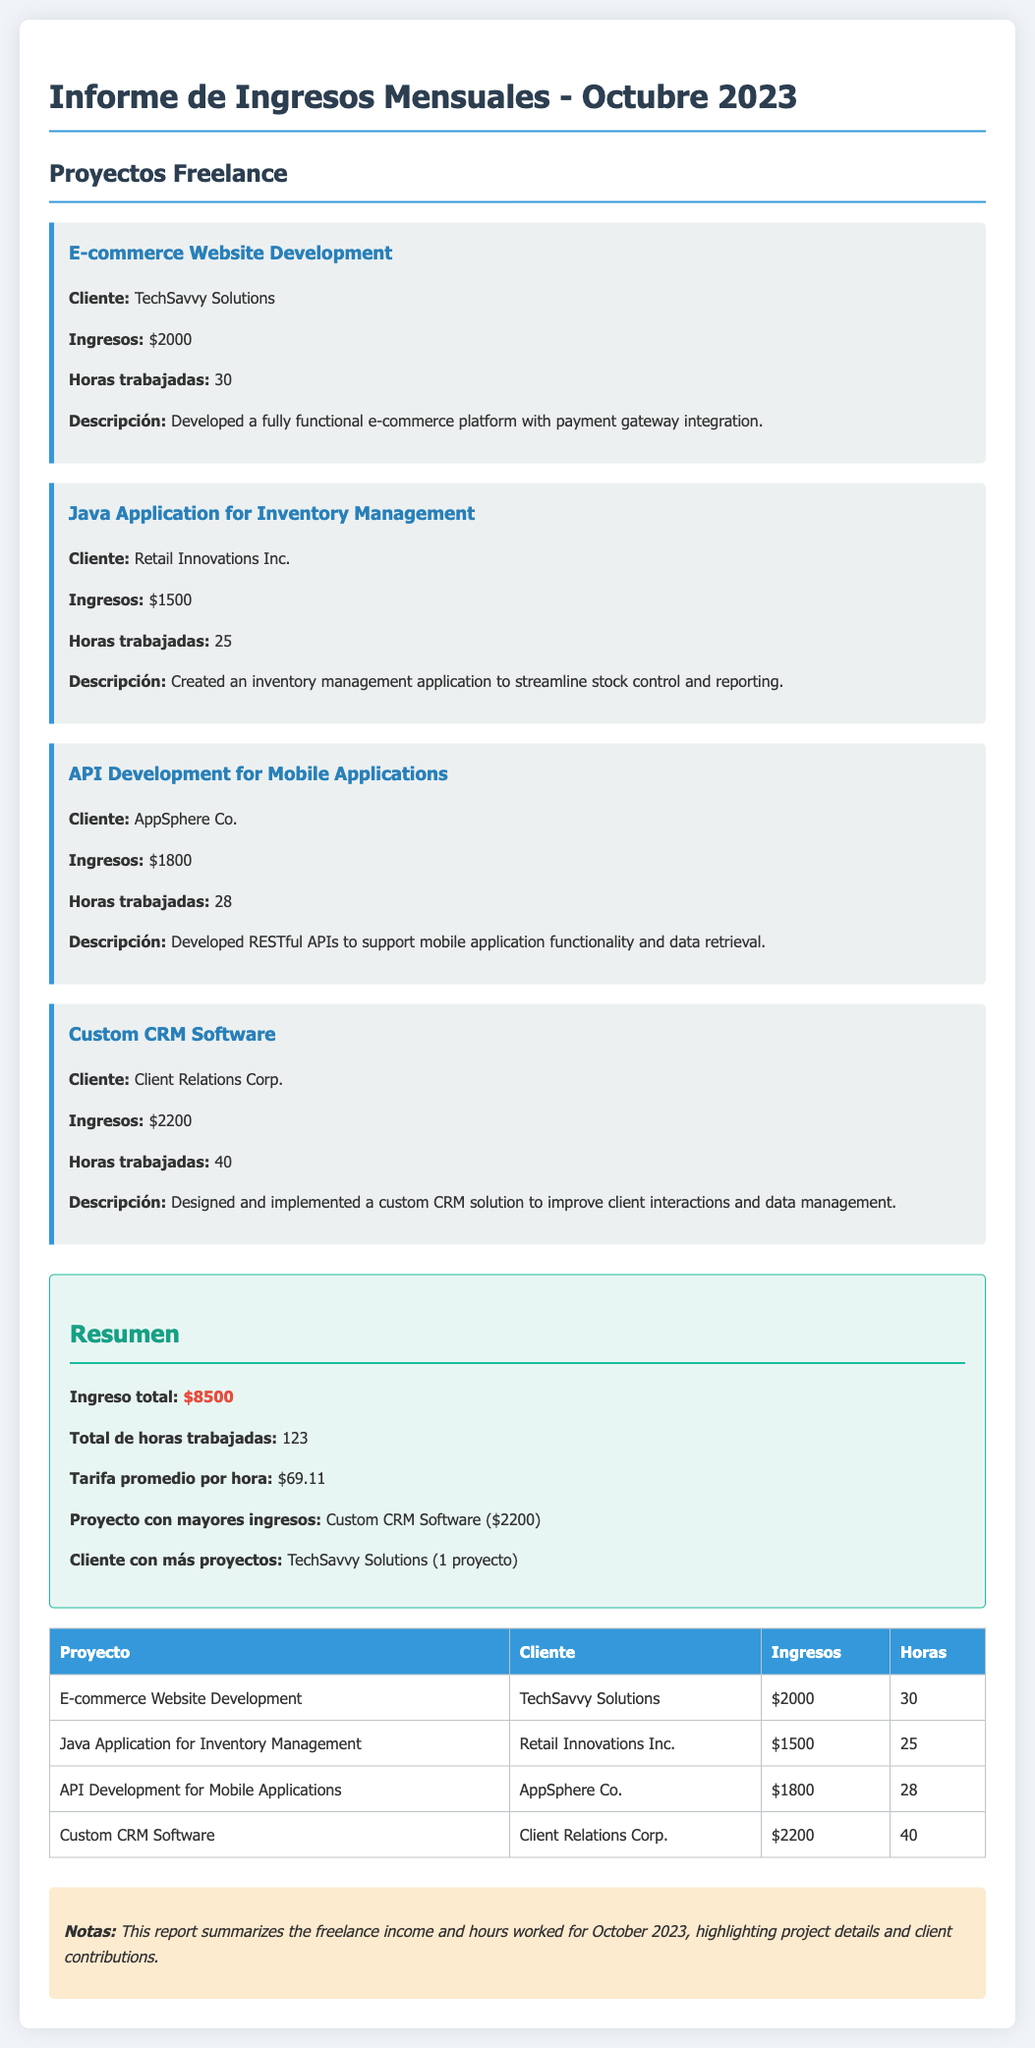what is the total revenue? The total revenue is the sum of all incomes from the projects listed in the document, which adds up to $8500.
Answer: $8500 who is the client for the API Development project? The client for the API Development for Mobile Applications project is mentioned in the document as AppSphere Co.
Answer: AppSphere Co how many hours were worked on the Custom CRM Software project? The document specifies that 40 hours were worked on the Custom CRM Software project.
Answer: 40 which project generated the highest income? The project that generated the highest income is detailed in the summary section as Custom CRM Software, with an income of $2200.
Answer: Custom CRM Software what is the average hourly rate calculated from the total income and hours worked? The average hourly rate is calculated as total income divided by total hours worked, resulting in a rate of $69.11.
Answer: $69.11 how many projects were completed for TechSavvy Solutions? The document indicates that there is 1 project completed for the client TechSavvy Solutions.
Answer: 1 proyecto how many total hours were worked across all projects? The total hours worked is provided in the summary as 123 hours.
Answer: 123 what is the description of the E-commerce Website Development project? The description specifies that a fully functional e-commerce platform with payment gateway integration was developed.
Answer: Developed a fully functional e-commerce platform with payment gateway integration what type of report is this document? This document is a Monthly Income Report summarizing freelance work and earnings.
Answer: Informe de Ingresos Mensuales 